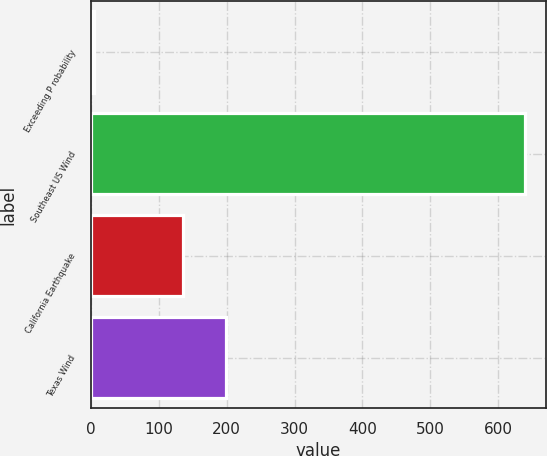Convert chart to OTSL. <chart><loc_0><loc_0><loc_500><loc_500><bar_chart><fcel>Exceeding P robability<fcel>Southeast US Wind<fcel>California Earthquake<fcel>Texas Wind<nl><fcel>5<fcel>639<fcel>136<fcel>199.4<nl></chart> 